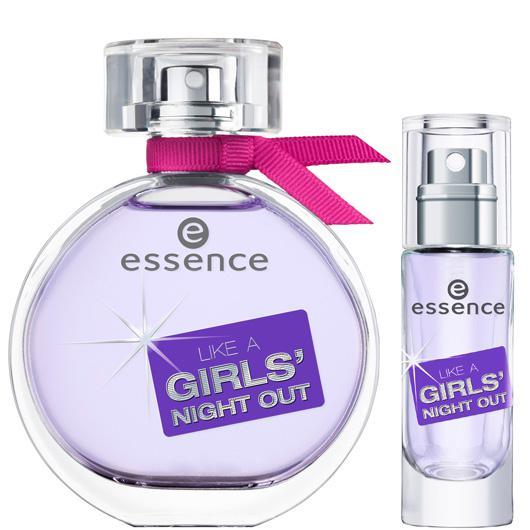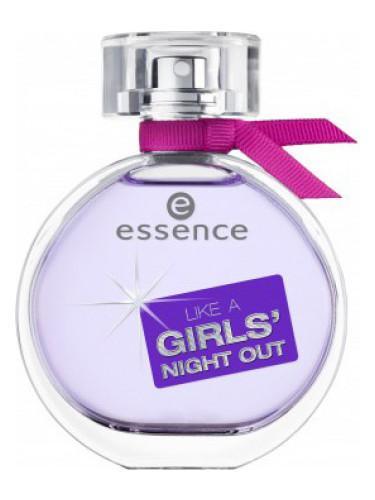The first image is the image on the left, the second image is the image on the right. For the images displayed, is the sentence "One bottle has a purple bow." factually correct? Answer yes or no. No. 